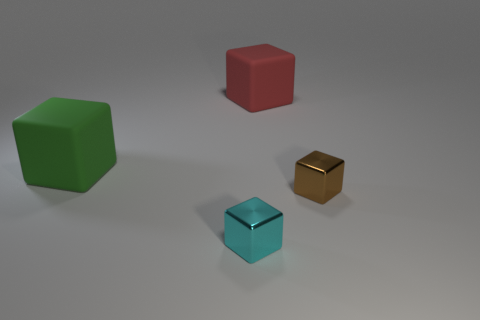What number of other objects are there of the same size as the red rubber block?
Keep it short and to the point. 1. Does the block that is in front of the brown cube have the same material as the large green block?
Give a very brief answer. No. How many other things are the same shape as the tiny cyan object?
Give a very brief answer. 3. Are there the same number of small cyan shiny things that are in front of the small brown shiny object and small cyan metal things behind the large red cube?
Keep it short and to the point. No. What shape is the small object that is on the left side of the object to the right of the matte cube that is to the right of the big green cube?
Offer a very short reply. Cube. Do the large object that is to the left of the red matte object and the small block that is on the left side of the red matte block have the same material?
Give a very brief answer. No. There is a small object that is on the right side of the large red thing; what is its shape?
Provide a succinct answer. Cube. Are there fewer green matte objects than large rubber things?
Give a very brief answer. Yes. Are there any tiny cyan metal objects that are right of the metal block that is to the left of the small metal thing behind the tiny cyan cube?
Your response must be concise. No. What number of metallic things are cyan blocks or small green cylinders?
Make the answer very short. 1. 